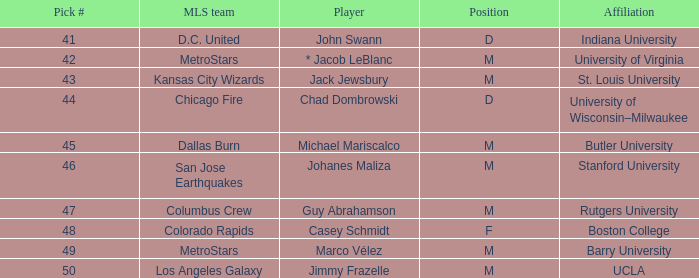For the mls, which team is assigned the pick number 41? D.C. United. 